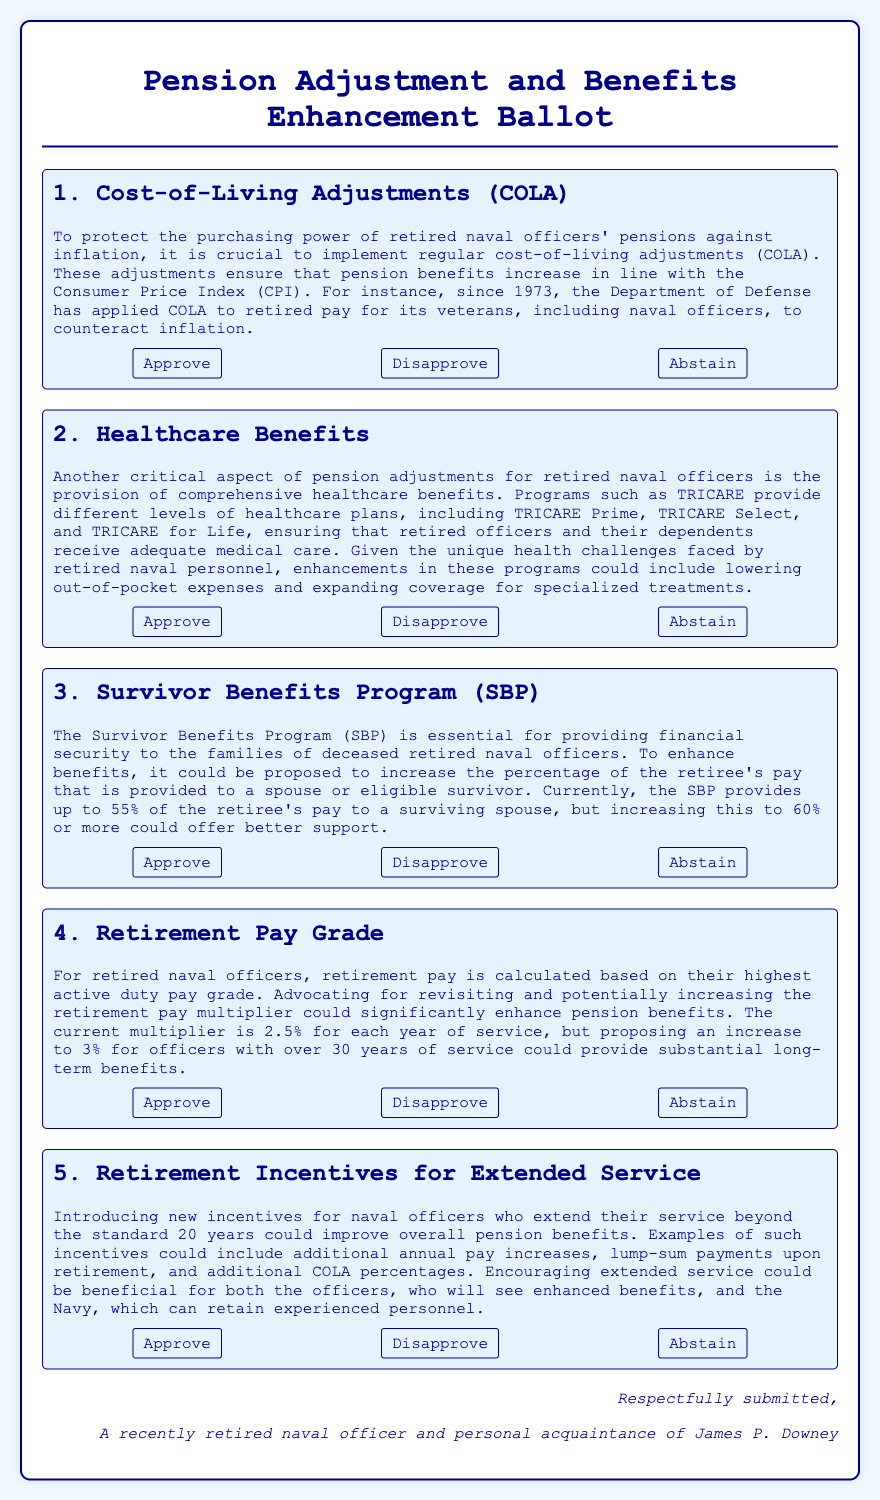What is the title of the document? The title of the document is displayed prominently at the top of the ballot, indicating its purpose.
Answer: Pension Adjustment and Benefits Enhancement Ballot How many items are listed on the ballot? The document contains several sections, each representing a separate item that requires voting.
Answer: Five What is the main focus of item 1? Item 1 specifically addresses the need for adjustments to protect the purchasing power of retired naval officers' pensions.
Answer: Cost-of-Living Adjustments What percentage of the retiree's pay does the Survivor Benefits Program currently provide? The document states the current benefit level provided by the SBP to a surviving spouse is mentioned clearly.
Answer: 55% What enhancement is proposed for survivor benefits? The document outlines a proposed increase to better support the families of deceased retired naval officers in the SBP.
Answer: 60% What does the document suggest about healthcare benefits? The text discusses the importance of comprehensive healthcare plans for retired officers, emphasizing improvements in specific areas.
Answer: Enhancements in healthcare programs How is retirement pay currently calculated? The document explains the basis on which retirement pay for officers is determined, mentioning a specific pay grade context.
Answer: Highest active duty pay grade What additional incentive is discussed for extended service? The document proposes that introducing incentives could enhance pension benefits for officers extending their service.
Answer: Additional annual pay increases Who is the document respectfully submitted by? The closing signature section clarifies who authored and submitted the ballot.
Answer: A recently retired naval officer and personal acquaintance of James P. Downey 